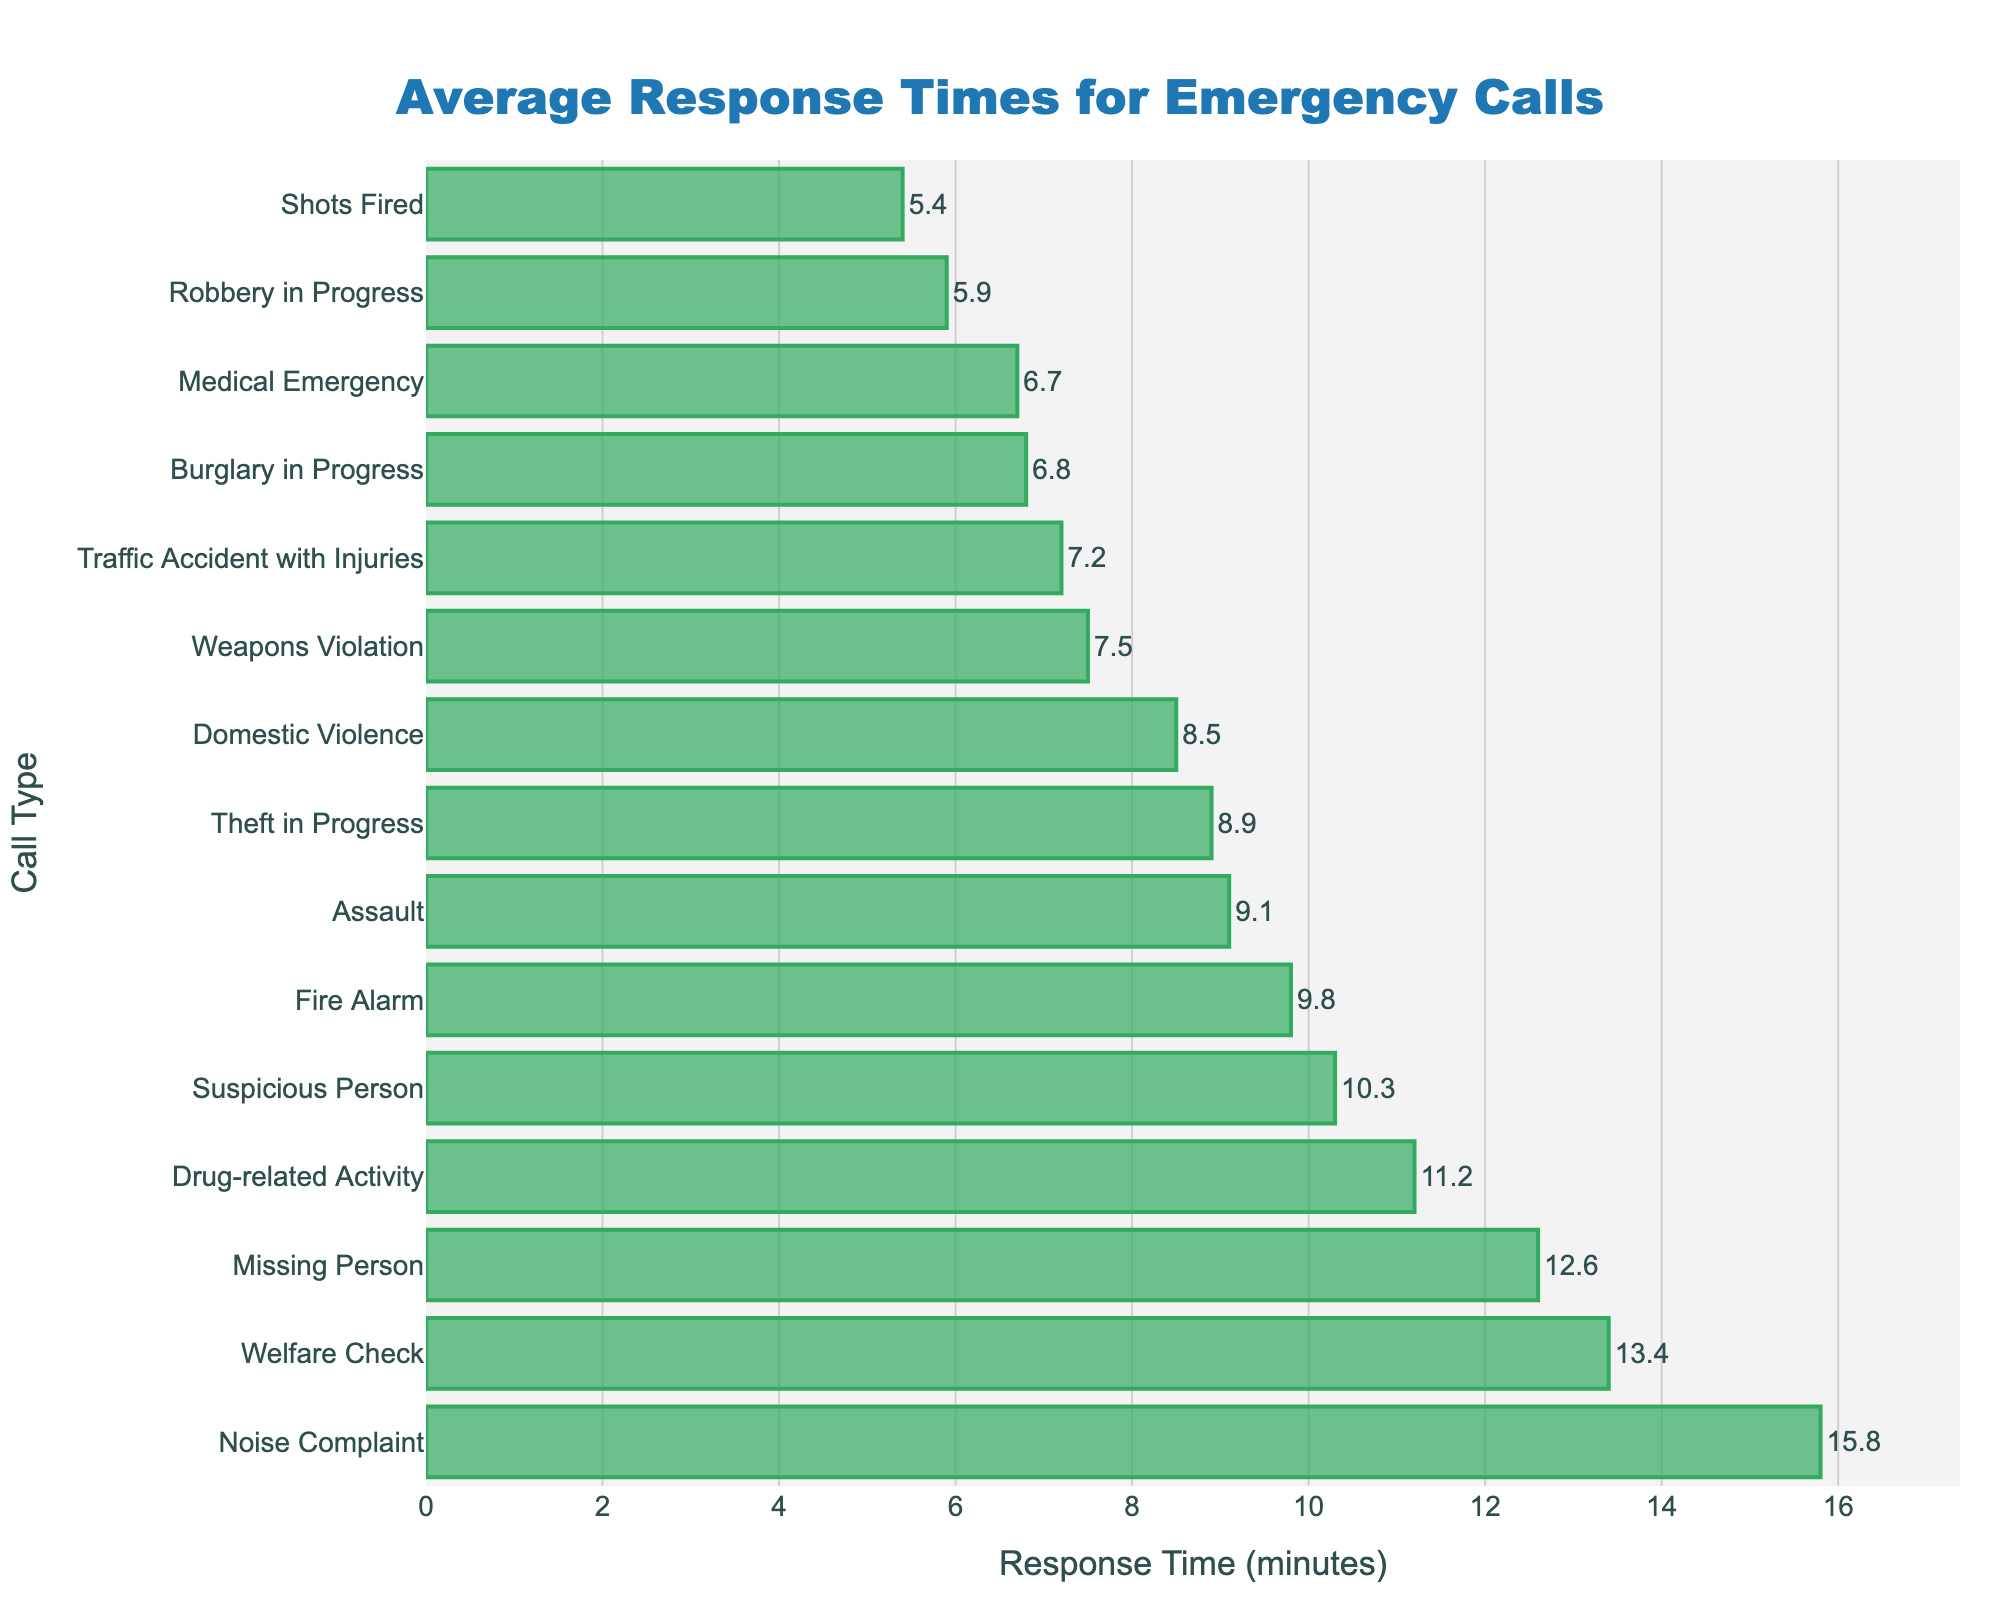What type of emergency call has the longest average response time? The bar that extends the farthest to the right represents the longest response time. This is marked by "Noise Complaint" at 15.8 minutes.
Answer: Noise Complaint Which type of emergency call has the shortest average response time? Identify the bar that is the shortest among all on the chart. The bar for "Shots Fired" is the shortest, indicating an average response time of 5.4 minutes.
Answer: Shots Fired What is the difference in average response time between a "Domestic Violence" call and a "Medical Emergency" call? Locate the bars for both "Domestic Violence" and "Medical Emergency". The values are 8.5 minutes and 6.7 minutes, respectively. Subtract 6.7 from 8.5 to get the difference, which is 1.8 minutes.
Answer: 1.8 minutes Is the average response time for a "Suspicious Person" call greater than that for a "Burglary in Progress" call? Compare the bar lengths for "Suspicious Person" and "Burglary in Progress". The bar for "Suspicious Person" (10.3 minutes) is longer than that for "Burglary in Progress" (6.8 minutes).
Answer: Yes What are the average response times for the top three slowest types of emergency calls? Identify the three longest bars. The bars are for "Noise Complaint" (15.8 minutes), "Welfare Check" (13.4 minutes), and "Missing Person" (12.6 minutes).
Answer: 15.8, 13.4, 12.6 minutes Which types of emergency calls have an average response time of less than 7 minutes? Identify the bars that do not extend beyond the 7-minute mark. These are "Traffic Accident with Injuries" (7.2 minutes needs 0.2-minute adjustment), "Shots Fired" (5.4 minutes), "Medical Emergency" (6.7 minutes), and "Robbery in Progress" (5.9 minutes). Note: The average times specified must be adjusted slightly.
Answer: Shots Fired, Medical Emergency, Robbery in Progress What's the combined average response time for "Drug-related Activity" and "Weapons Violation"? Find the response times for both types. Average response times are 11.2 minutes and 7.5 minutes for "Drug-related Activity" and "Weapons Violation", respectively. Add 11.2 and 7.5 to get 18.7 minutes.
Answer: 18.7 minutes List the emergency call types with response times greater than 10 minutes. Identify bars that extend beyond the 10-minute mark. These are "Suspicious Person" (10.3 minutes), "Missing Person" (12.6 minutes), "Drug-related Activity" (11.2 minutes), "Noise Complaint" (15.8 minutes), and "Welfare Check" (13.4 minutes).
Answer: Suspicious Person, Missing Person, Drug-related Activity, Noise Complaint, Welfare Check What is the median response time for all types of emergency calls? List all response times in ascending order: 5.4, 5.9, 6.7, 6.8, 7.2, 7.5, 8.5, 8.9, 9.1, 9.8, 10.3, 11.2, 12.6, 13.4, 15.8. The middle value, which is the 8th value, is 8.9. Thus, the median response time is 8.9 minutes.
Answer: 8.9 minutes 